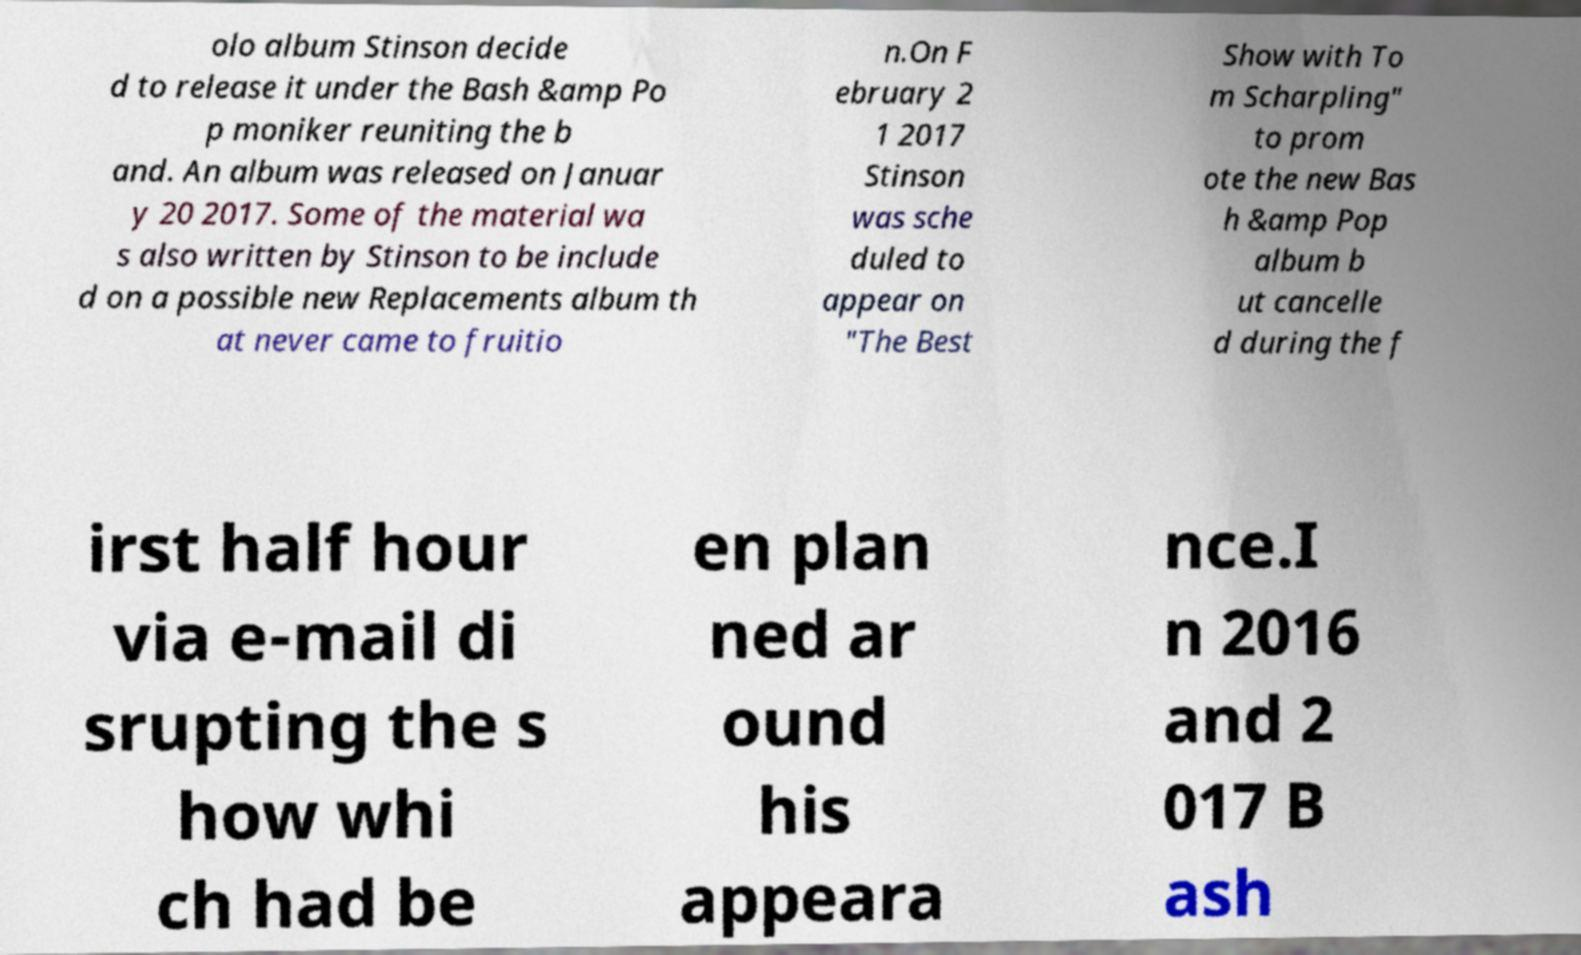There's text embedded in this image that I need extracted. Can you transcribe it verbatim? olo album Stinson decide d to release it under the Bash &amp Po p moniker reuniting the b and. An album was released on Januar y 20 2017. Some of the material wa s also written by Stinson to be include d on a possible new Replacements album th at never came to fruitio n.On F ebruary 2 1 2017 Stinson was sche duled to appear on "The Best Show with To m Scharpling" to prom ote the new Bas h &amp Pop album b ut cancelle d during the f irst half hour via e-mail di srupting the s how whi ch had be en plan ned ar ound his appeara nce.I n 2016 and 2 017 B ash 